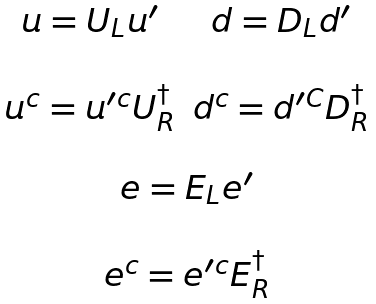<formula> <loc_0><loc_0><loc_500><loc_500>\begin{array} { c } \begin{array} { c c } u = U _ { L } u ^ { \prime } & d = D _ { L } d ^ { \prime } \\ \\ u ^ { c } = u ^ { \prime c } U _ { R } ^ { \dagger } & d ^ { c } = d ^ { \prime C } D _ { R } ^ { \dagger } \\ \\ \end{array} \\ e = E _ { L } e ^ { \prime } \\ \\ e ^ { c } = e ^ { \prime c } E _ { R } ^ { \dagger } \end{array}</formula> 